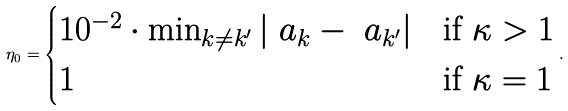<formula> <loc_0><loc_0><loc_500><loc_500>\eta _ { 0 } = \begin{cases} 1 0 ^ { - 2 } \cdot \min _ { k \neq k ^ { \prime } } | \ a _ { k } - \ a _ { k ^ { \prime } } | & \text {if } \kappa > 1 \\ 1 & \text {if } \kappa = 1 \end{cases} .</formula> 